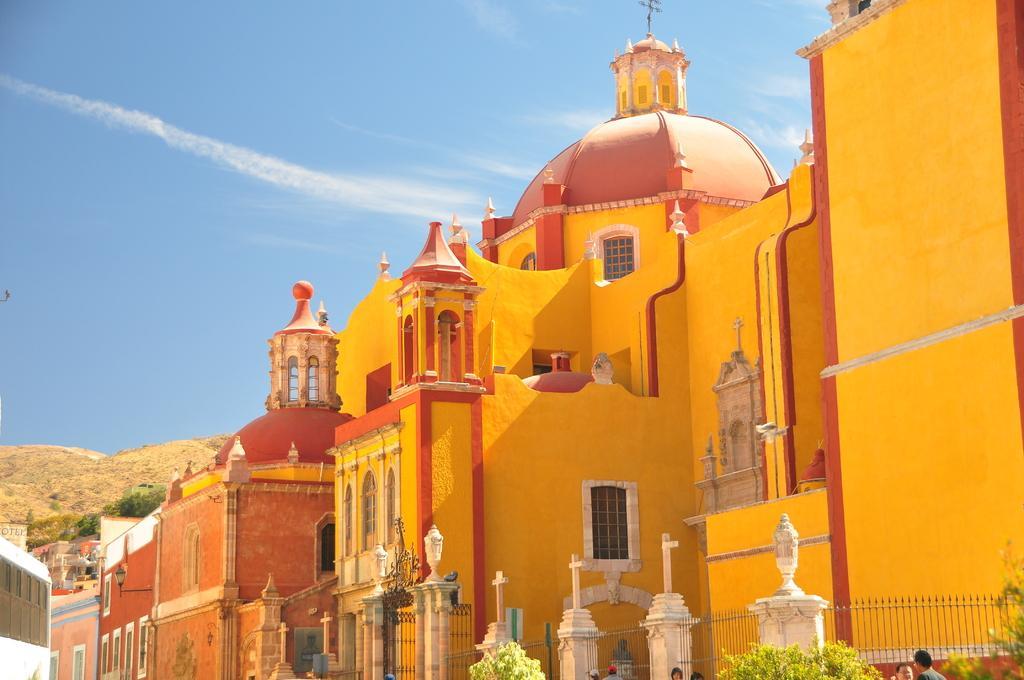How would you summarize this image in a sentence or two? In the picture I can see the castle construction and there is a dome construction at the top of the castle. I can see the metal grill fence, trees and a few persons at the bottom of the picture. It is looking like a bus on the bottom left side of the picture. In the background, I can see the hills. There are clouds in the sky. 